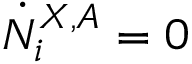<formula> <loc_0><loc_0><loc_500><loc_500>\dot { N } _ { i } ^ { X , A } = 0</formula> 